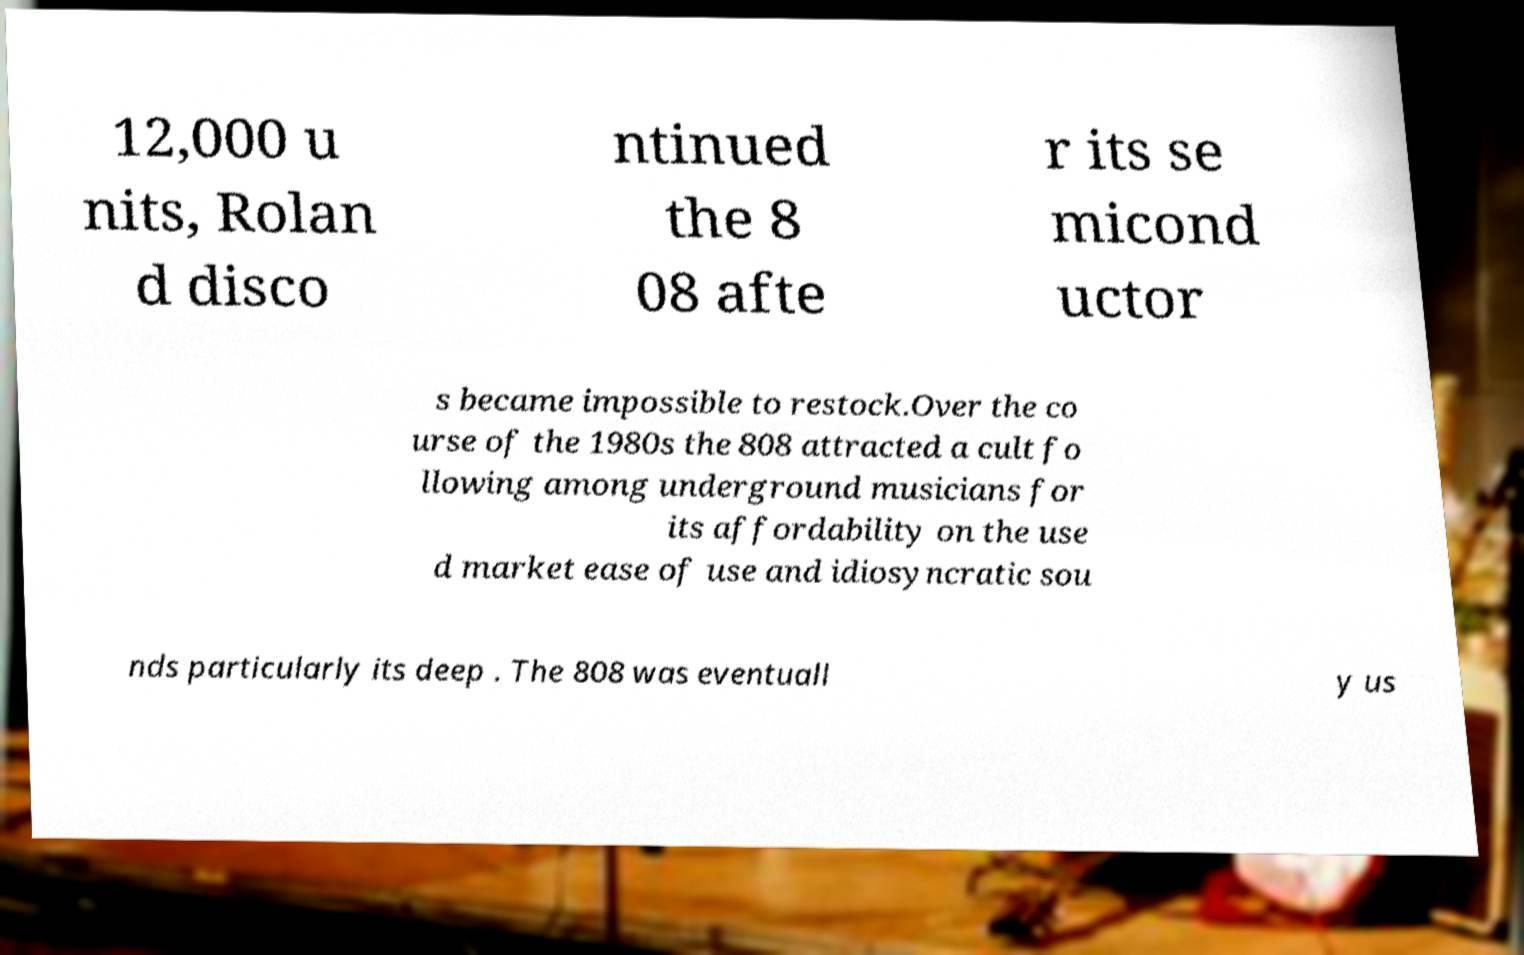Can you accurately transcribe the text from the provided image for me? 12,000 u nits, Rolan d disco ntinued the 8 08 afte r its se micond uctor s became impossible to restock.Over the co urse of the 1980s the 808 attracted a cult fo llowing among underground musicians for its affordability on the use d market ease of use and idiosyncratic sou nds particularly its deep . The 808 was eventuall y us 